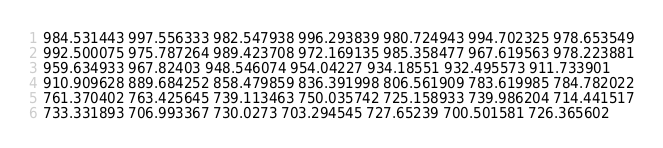Convert code to text. <code><loc_0><loc_0><loc_500><loc_500><_XML_>984.531443 997.556333 982.547938 996.293839 980.724943 994.702325 978.653549
992.500075 975.787264 989.423708 972.169135 985.358477 967.619563 978.223881
959.634933 967.82403 948.546074 954.04227 934.18551 932.495573 911.733901
910.909628 889.684252 858.479859 836.391998 806.561909 783.619985 784.782022
761.370402 763.425645 739.113463 750.035742 725.158933 739.986204 714.441517
733.331893 706.993367 730.0273 703.294545 727.65239 700.501581 726.365602</code> 